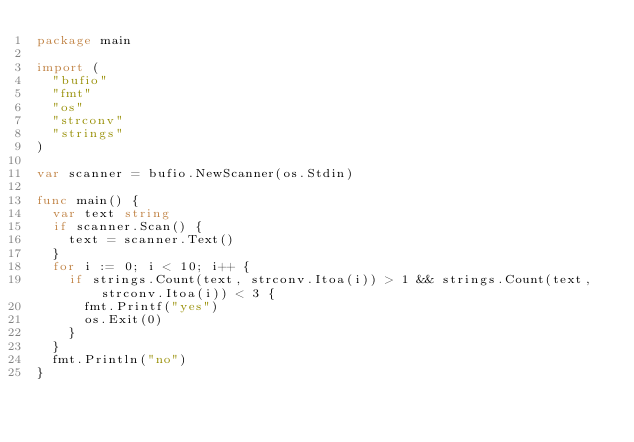<code> <loc_0><loc_0><loc_500><loc_500><_Go_>package main

import (
	"bufio"
	"fmt"
	"os"
	"strconv"
	"strings"
)

var scanner = bufio.NewScanner(os.Stdin)

func main() {
	var text string
	if scanner.Scan() {
		text = scanner.Text()
	}
	for i := 0; i < 10; i++ {
		if strings.Count(text, strconv.Itoa(i)) > 1 && strings.Count(text, strconv.Itoa(i)) < 3 {
			fmt.Printf("yes")
			os.Exit(0)
		}
	}
	fmt.Println("no")
}
</code> 